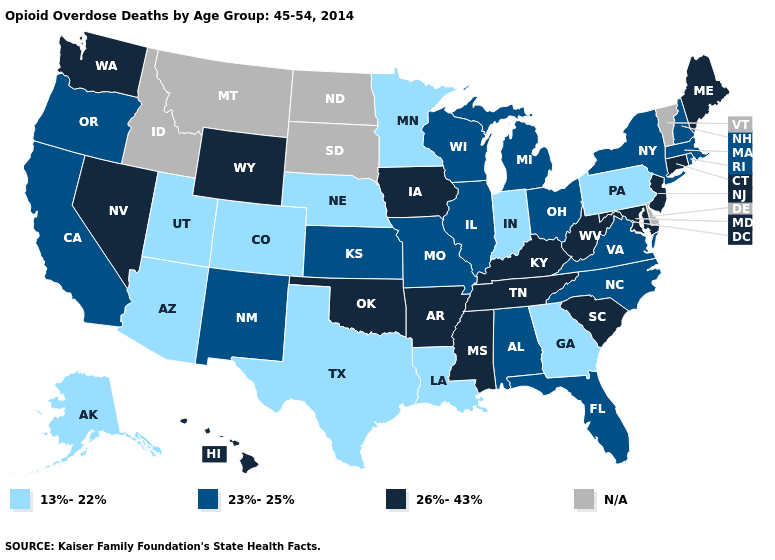What is the highest value in the USA?
Short answer required. 26%-43%. Is the legend a continuous bar?
Write a very short answer. No. Name the states that have a value in the range 26%-43%?
Answer briefly. Arkansas, Connecticut, Hawaii, Iowa, Kentucky, Maine, Maryland, Mississippi, Nevada, New Jersey, Oklahoma, South Carolina, Tennessee, Washington, West Virginia, Wyoming. Which states have the highest value in the USA?
Be succinct. Arkansas, Connecticut, Hawaii, Iowa, Kentucky, Maine, Maryland, Mississippi, Nevada, New Jersey, Oklahoma, South Carolina, Tennessee, Washington, West Virginia, Wyoming. What is the highest value in the USA?
Keep it brief. 26%-43%. Name the states that have a value in the range N/A?
Quick response, please. Delaware, Idaho, Montana, North Dakota, South Dakota, Vermont. How many symbols are there in the legend?
Short answer required. 4. Name the states that have a value in the range 26%-43%?
Short answer required. Arkansas, Connecticut, Hawaii, Iowa, Kentucky, Maine, Maryland, Mississippi, Nevada, New Jersey, Oklahoma, South Carolina, Tennessee, Washington, West Virginia, Wyoming. Does South Carolina have the highest value in the USA?
Keep it brief. Yes. What is the highest value in states that border South Carolina?
Be succinct. 23%-25%. Name the states that have a value in the range N/A?
Give a very brief answer. Delaware, Idaho, Montana, North Dakota, South Dakota, Vermont. Which states have the lowest value in the West?
Quick response, please. Alaska, Arizona, Colorado, Utah. Name the states that have a value in the range N/A?
Write a very short answer. Delaware, Idaho, Montana, North Dakota, South Dakota, Vermont. What is the value of Arizona?
Give a very brief answer. 13%-22%. 